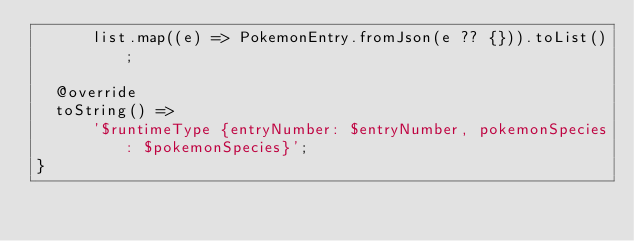<code> <loc_0><loc_0><loc_500><loc_500><_Dart_>      list.map((e) => PokemonEntry.fromJson(e ?? {})).toList();

  @override
  toString() =>
      '$runtimeType {entryNumber: $entryNumber, pokemonSpecies: $pokemonSpecies}';
}
</code> 